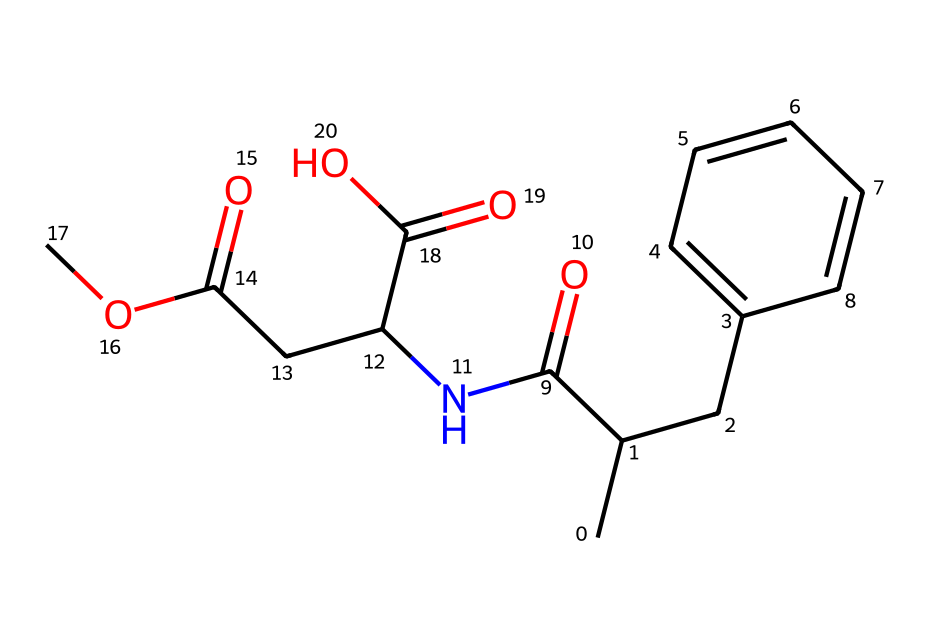What is the molecular formula of this compound? To determine the molecular formula, count the number of each type of atom present in the SMILES representation. The compound contains 15 carbon (C) atoms, 17 hydrogen (H) atoms, 3 nitrogen (N) atoms, and 5 oxygen (O) atoms, leading to the formula C15H17N3O5.
Answer: C15H17N3O5 How many rings are present in this molecule? By analyzing the structure represented by the SMILES, we see there is one aromatic ring (the benzene ring) evident in the CC1=CC=CC=C1 notation.
Answer: 1 What type of functional group is indicated by the presence of the –C(=O)O? The presence of the –C(=O)O group indicates a carboxylic acid functional group, as it contains a carbonyl (C=O) bonded to a hydroxyl (-OH) group.
Answer: carboxylic acid Does this compound contain any elements other than C, H, N, and O? Based on the SMILES representation, the only elements present are carbon, hydrogen, nitrogen, and oxygen. There are no other elements indicated in the structure.
Answer: No What can be inferred about the sweetness of this additive based on its structure? The structure indicates the presence of multiple functional groups, including nitrogen atoms, which are often associated with sweet-tasting compounds. Furthermore, the overall complexity and presence of specific elements suggest potential sweetening properties, common in artificial sweeteners.
Answer: Sweetness potential What is the total number of oxygen atoms in this compound? By counting the oxygen atoms in the SMILES representation, we identify five distinct oxygen atoms present in various functional groups throughout the structure.
Answer: 5 Which part of this molecule contributes to its solubility in water? The presence of the multiple polar functional groups, particularly the hydroxyl group in –C(=O)O, contributes to the overall polarity of the molecule, enhancing its solubility in water.
Answer: Hydroxyl groups 